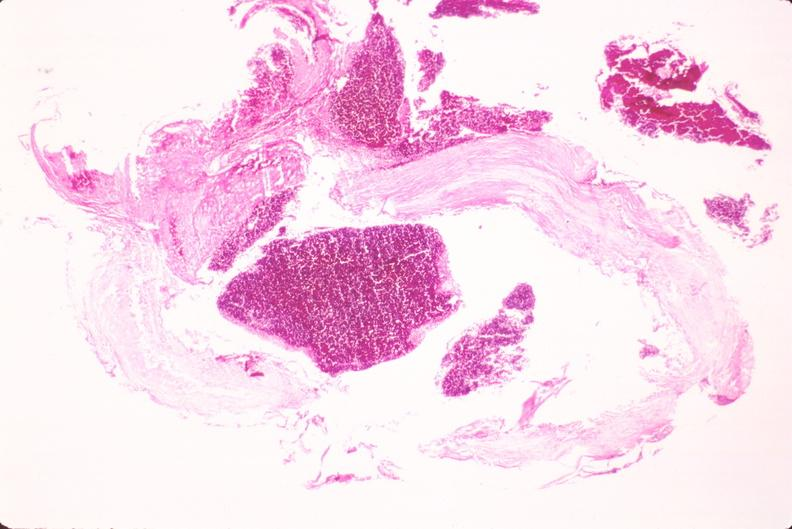where is this in?
Answer the question using a single word or phrase. In vasculature 